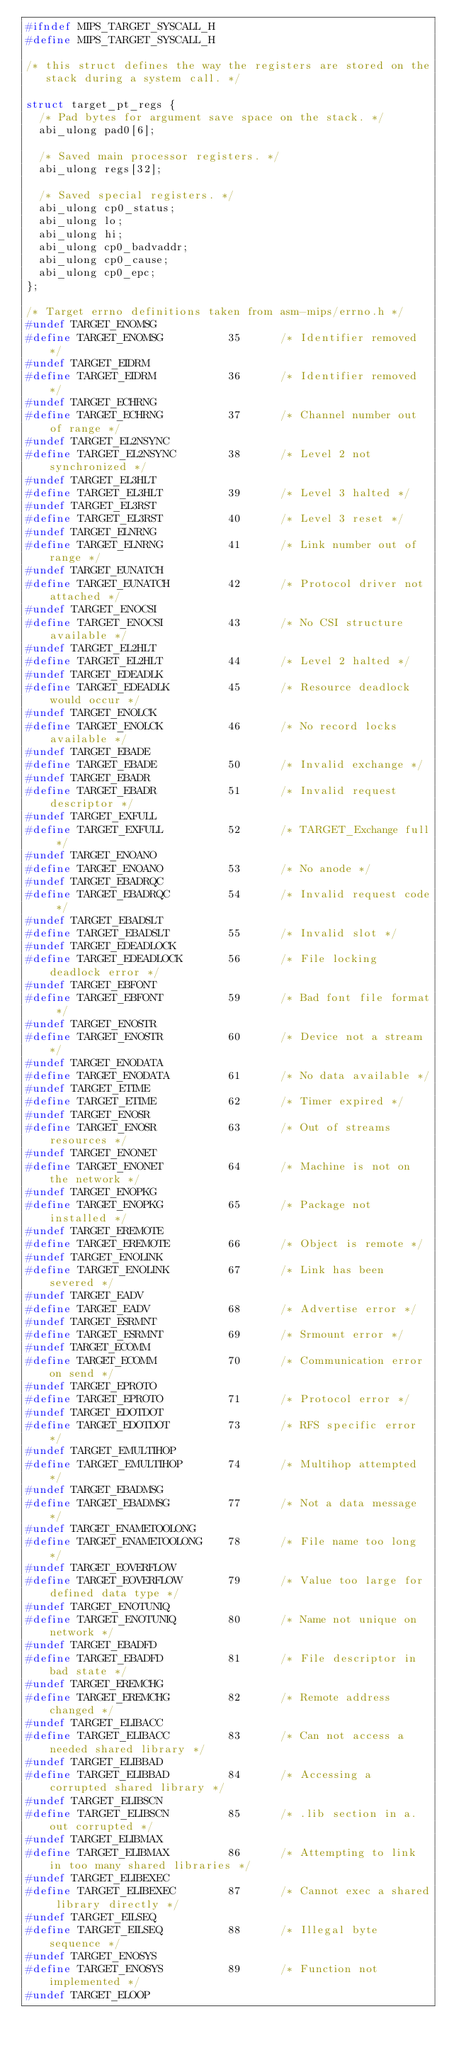Convert code to text. <code><loc_0><loc_0><loc_500><loc_500><_C_>#ifndef MIPS_TARGET_SYSCALL_H
#define MIPS_TARGET_SYSCALL_H

/* this struct defines the way the registers are stored on the
   stack during a system call. */

struct target_pt_regs {
	/* Pad bytes for argument save space on the stack. */
	abi_ulong pad0[6];

	/* Saved main processor registers. */
	abi_ulong regs[32];

	/* Saved special registers. */
	abi_ulong cp0_status;
	abi_ulong lo;
	abi_ulong hi;
	abi_ulong cp0_badvaddr;
	abi_ulong cp0_cause;
	abi_ulong cp0_epc;
};

/* Target errno definitions taken from asm-mips/errno.h */
#undef TARGET_ENOMSG
#define TARGET_ENOMSG          35      /* Identifier removed */
#undef TARGET_EIDRM
#define TARGET_EIDRM           36      /* Identifier removed */
#undef TARGET_ECHRNG
#define TARGET_ECHRNG          37      /* Channel number out of range */
#undef TARGET_EL2NSYNC
#define TARGET_EL2NSYNC        38      /* Level 2 not synchronized */
#undef TARGET_EL3HLT
#define TARGET_EL3HLT          39      /* Level 3 halted */
#undef TARGET_EL3RST
#define TARGET_EL3RST          40      /* Level 3 reset */
#undef TARGET_ELNRNG
#define TARGET_ELNRNG          41      /* Link number out of range */
#undef TARGET_EUNATCH
#define TARGET_EUNATCH         42      /* Protocol driver not attached */
#undef TARGET_ENOCSI
#define TARGET_ENOCSI          43      /* No CSI structure available */
#undef TARGET_EL2HLT
#define TARGET_EL2HLT          44      /* Level 2 halted */
#undef TARGET_EDEADLK
#define TARGET_EDEADLK         45      /* Resource deadlock would occur */
#undef TARGET_ENOLCK
#define TARGET_ENOLCK          46      /* No record locks available */
#undef TARGET_EBADE
#define TARGET_EBADE           50      /* Invalid exchange */
#undef TARGET_EBADR
#define TARGET_EBADR           51      /* Invalid request descriptor */
#undef TARGET_EXFULL
#define TARGET_EXFULL          52      /* TARGET_Exchange full */
#undef TARGET_ENOANO
#define TARGET_ENOANO          53      /* No anode */
#undef TARGET_EBADRQC
#define TARGET_EBADRQC         54      /* Invalid request code */
#undef TARGET_EBADSLT
#define TARGET_EBADSLT         55      /* Invalid slot */
#undef TARGET_EDEADLOCK
#define TARGET_EDEADLOCK       56      /* File locking deadlock error */
#undef TARGET_EBFONT
#define TARGET_EBFONT          59      /* Bad font file format */
#undef TARGET_ENOSTR
#define TARGET_ENOSTR          60      /* Device not a stream */
#undef TARGET_ENODATA
#define TARGET_ENODATA         61      /* No data available */
#undef TARGET_ETIME
#define TARGET_ETIME           62      /* Timer expired */
#undef TARGET_ENOSR
#define TARGET_ENOSR           63      /* Out of streams resources */
#undef TARGET_ENONET
#define TARGET_ENONET          64      /* Machine is not on the network */
#undef TARGET_ENOPKG
#define TARGET_ENOPKG          65      /* Package not installed */
#undef TARGET_EREMOTE
#define TARGET_EREMOTE         66      /* Object is remote */
#undef TARGET_ENOLINK
#define TARGET_ENOLINK         67      /* Link has been severed */
#undef TARGET_EADV
#define TARGET_EADV            68      /* Advertise error */
#undef TARGET_ESRMNT
#define TARGET_ESRMNT          69      /* Srmount error */
#undef TARGET_ECOMM
#define TARGET_ECOMM           70      /* Communication error on send */
#undef TARGET_EPROTO
#define TARGET_EPROTO          71      /* Protocol error */
#undef TARGET_EDOTDOT
#define TARGET_EDOTDOT         73      /* RFS specific error */
#undef TARGET_EMULTIHOP
#define TARGET_EMULTIHOP       74      /* Multihop attempted */
#undef TARGET_EBADMSG
#define TARGET_EBADMSG         77      /* Not a data message */
#undef TARGET_ENAMETOOLONG
#define TARGET_ENAMETOOLONG    78      /* File name too long */
#undef TARGET_EOVERFLOW
#define TARGET_EOVERFLOW       79      /* Value too large for defined data type */
#undef TARGET_ENOTUNIQ
#define TARGET_ENOTUNIQ        80      /* Name not unique on network */
#undef TARGET_EBADFD
#define TARGET_EBADFD          81      /* File descriptor in bad state */
#undef TARGET_EREMCHG
#define TARGET_EREMCHG         82      /* Remote address changed */
#undef TARGET_ELIBACC
#define TARGET_ELIBACC         83      /* Can not access a needed shared library */
#undef TARGET_ELIBBAD
#define TARGET_ELIBBAD         84      /* Accessing a corrupted shared library */
#undef TARGET_ELIBSCN
#define TARGET_ELIBSCN         85      /* .lib section in a.out corrupted */
#undef TARGET_ELIBMAX
#define TARGET_ELIBMAX         86      /* Attempting to link in too many shared libraries */
#undef TARGET_ELIBEXEC
#define TARGET_ELIBEXEC        87      /* Cannot exec a shared library directly */
#undef TARGET_EILSEQ
#define TARGET_EILSEQ          88      /* Illegal byte sequence */
#undef TARGET_ENOSYS
#define TARGET_ENOSYS          89      /* Function not implemented */
#undef TARGET_ELOOP</code> 